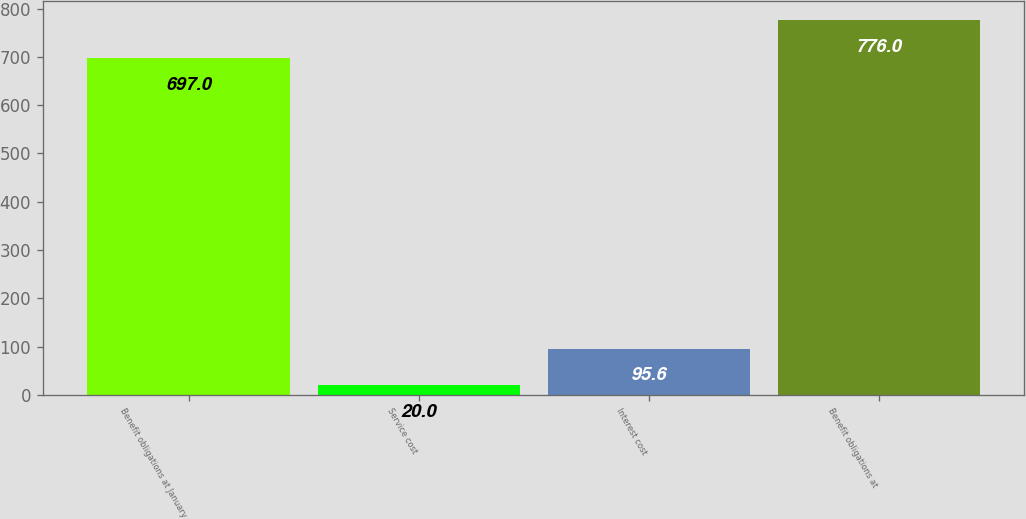Convert chart to OTSL. <chart><loc_0><loc_0><loc_500><loc_500><bar_chart><fcel>Benefit obligations at January<fcel>Service cost<fcel>Interest cost<fcel>Benefit obligations at<nl><fcel>697<fcel>20<fcel>95.6<fcel>776<nl></chart> 